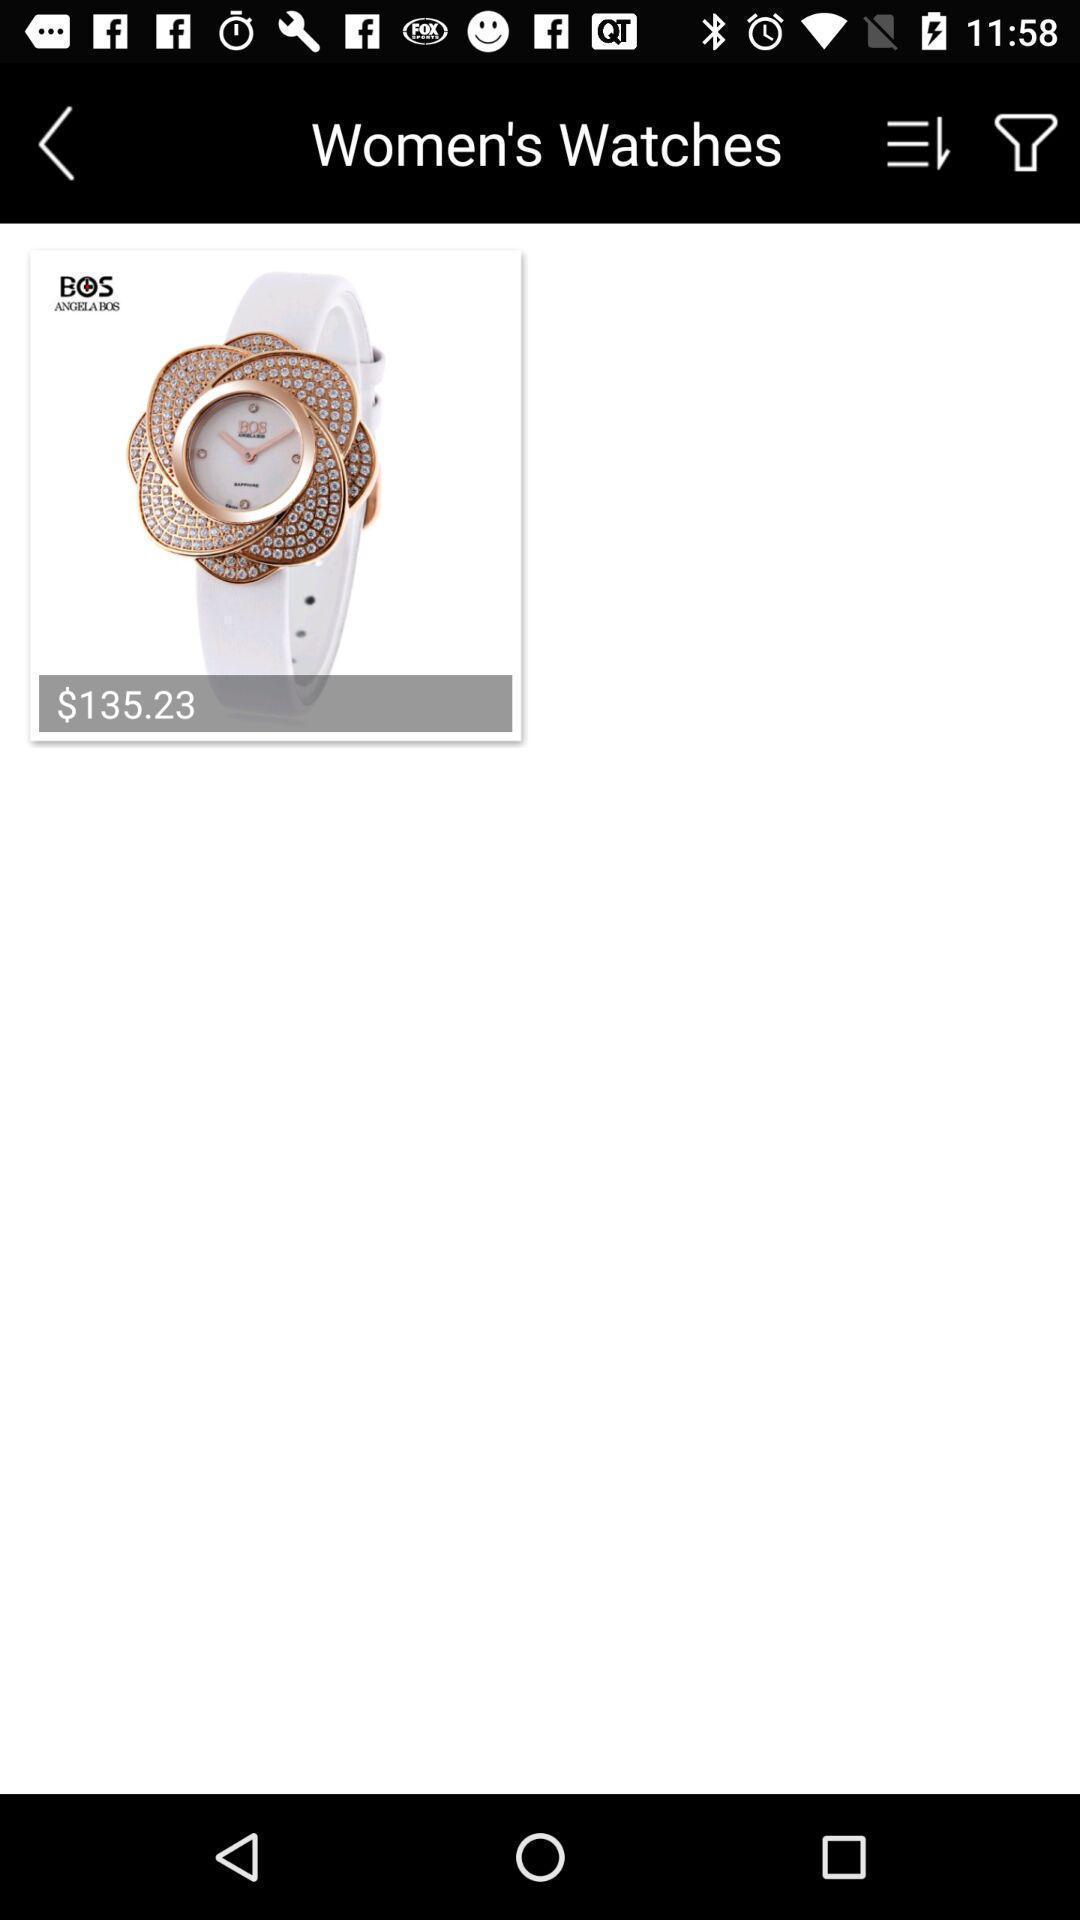Provide a detailed account of this screenshot. Page with an item in a shopping application. 